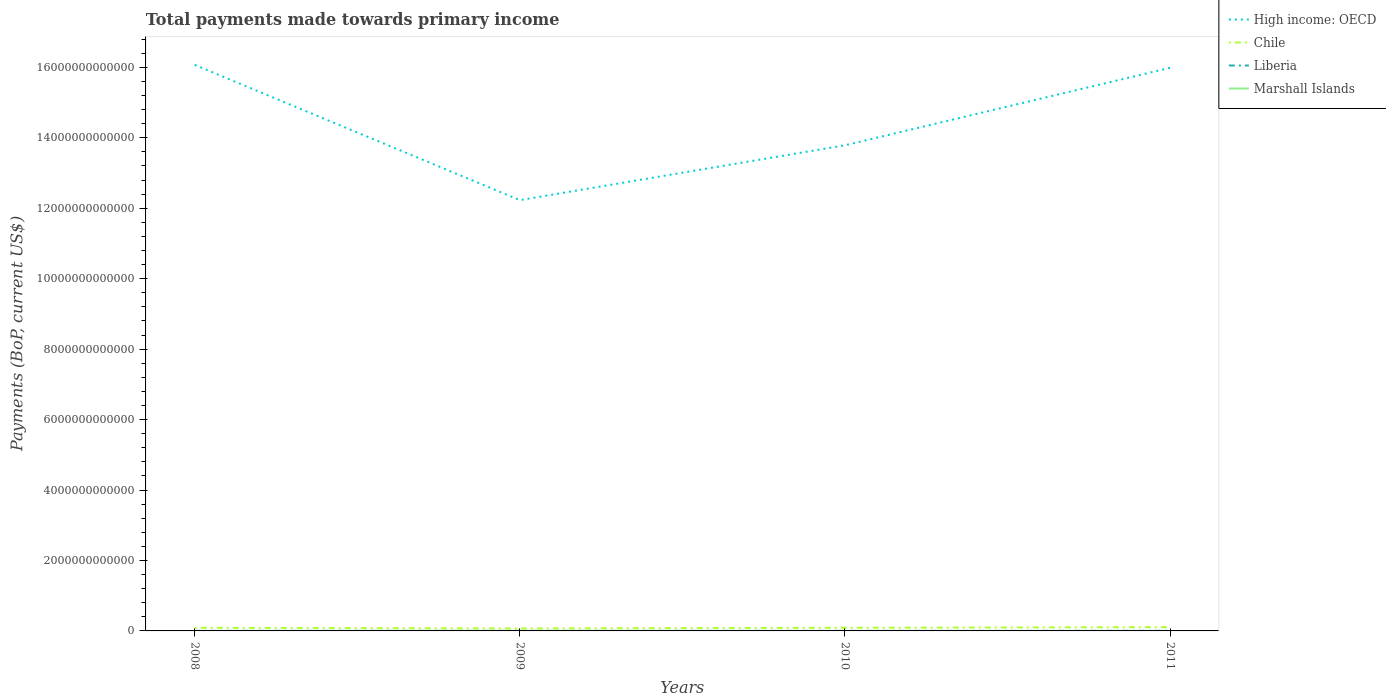How many different coloured lines are there?
Offer a very short reply. 4. Does the line corresponding to Liberia intersect with the line corresponding to High income: OECD?
Your response must be concise. No. Is the number of lines equal to the number of legend labels?
Provide a short and direct response. Yes. Across all years, what is the maximum total payments made towards primary income in Marshall Islands?
Provide a succinct answer. 1.52e+08. In which year was the total payments made towards primary income in Liberia maximum?
Ensure brevity in your answer.  2010. What is the total total payments made towards primary income in Liberia in the graph?
Offer a terse response. 5.06e+08. What is the difference between the highest and the second highest total payments made towards primary income in Chile?
Ensure brevity in your answer.  3.89e+1. What is the difference between the highest and the lowest total payments made towards primary income in Marshall Islands?
Provide a succinct answer. 2. How many lines are there?
Offer a very short reply. 4. How many years are there in the graph?
Offer a terse response. 4. What is the difference between two consecutive major ticks on the Y-axis?
Provide a succinct answer. 2.00e+12. Does the graph contain any zero values?
Offer a terse response. No. Where does the legend appear in the graph?
Provide a short and direct response. Top right. What is the title of the graph?
Your answer should be very brief. Total payments made towards primary income. Does "Romania" appear as one of the legend labels in the graph?
Your response must be concise. No. What is the label or title of the X-axis?
Offer a terse response. Years. What is the label or title of the Y-axis?
Ensure brevity in your answer.  Payments (BoP, current US$). What is the Payments (BoP, current US$) of High income: OECD in 2008?
Give a very brief answer. 1.61e+13. What is the Payments (BoP, current US$) of Chile in 2008?
Your answer should be very brief. 8.92e+1. What is the Payments (BoP, current US$) in Liberia in 2008?
Make the answer very short. 2.31e+09. What is the Payments (BoP, current US$) of Marshall Islands in 2008?
Your response must be concise. 1.52e+08. What is the Payments (BoP, current US$) in High income: OECD in 2009?
Ensure brevity in your answer.  1.22e+13. What is the Payments (BoP, current US$) in Chile in 2009?
Offer a very short reply. 6.86e+1. What is the Payments (BoP, current US$) in Liberia in 2009?
Provide a short and direct response. 1.85e+09. What is the Payments (BoP, current US$) of Marshall Islands in 2009?
Make the answer very short. 1.70e+08. What is the Payments (BoP, current US$) in High income: OECD in 2010?
Give a very brief answer. 1.38e+13. What is the Payments (BoP, current US$) of Chile in 2010?
Make the answer very short. 8.99e+1. What is the Payments (BoP, current US$) of Liberia in 2010?
Make the answer very short. 1.80e+09. What is the Payments (BoP, current US$) of Marshall Islands in 2010?
Offer a very short reply. 1.76e+08. What is the Payments (BoP, current US$) of High income: OECD in 2011?
Keep it short and to the point. 1.60e+13. What is the Payments (BoP, current US$) of Chile in 2011?
Provide a succinct answer. 1.07e+11. What is the Payments (BoP, current US$) of Liberia in 2011?
Provide a short and direct response. 3.33e+09. What is the Payments (BoP, current US$) in Marshall Islands in 2011?
Your answer should be compact. 1.93e+08. Across all years, what is the maximum Payments (BoP, current US$) in High income: OECD?
Offer a very short reply. 1.61e+13. Across all years, what is the maximum Payments (BoP, current US$) of Chile?
Give a very brief answer. 1.07e+11. Across all years, what is the maximum Payments (BoP, current US$) in Liberia?
Offer a terse response. 3.33e+09. Across all years, what is the maximum Payments (BoP, current US$) of Marshall Islands?
Ensure brevity in your answer.  1.93e+08. Across all years, what is the minimum Payments (BoP, current US$) of High income: OECD?
Ensure brevity in your answer.  1.22e+13. Across all years, what is the minimum Payments (BoP, current US$) in Chile?
Offer a terse response. 6.86e+1. Across all years, what is the minimum Payments (BoP, current US$) in Liberia?
Your response must be concise. 1.80e+09. Across all years, what is the minimum Payments (BoP, current US$) of Marshall Islands?
Ensure brevity in your answer.  1.52e+08. What is the total Payments (BoP, current US$) in High income: OECD in the graph?
Your answer should be very brief. 5.81e+13. What is the total Payments (BoP, current US$) of Chile in the graph?
Keep it short and to the point. 3.55e+11. What is the total Payments (BoP, current US$) of Liberia in the graph?
Provide a succinct answer. 9.29e+09. What is the total Payments (BoP, current US$) in Marshall Islands in the graph?
Provide a succinct answer. 6.91e+08. What is the difference between the Payments (BoP, current US$) in High income: OECD in 2008 and that in 2009?
Offer a very short reply. 3.84e+12. What is the difference between the Payments (BoP, current US$) in Chile in 2008 and that in 2009?
Keep it short and to the point. 2.07e+1. What is the difference between the Payments (BoP, current US$) of Liberia in 2008 and that in 2009?
Give a very brief answer. 4.61e+08. What is the difference between the Payments (BoP, current US$) of Marshall Islands in 2008 and that in 2009?
Provide a succinct answer. -1.81e+07. What is the difference between the Payments (BoP, current US$) in High income: OECD in 2008 and that in 2010?
Offer a terse response. 2.28e+12. What is the difference between the Payments (BoP, current US$) in Chile in 2008 and that in 2010?
Ensure brevity in your answer.  -6.36e+08. What is the difference between the Payments (BoP, current US$) of Liberia in 2008 and that in 2010?
Make the answer very short. 5.06e+08. What is the difference between the Payments (BoP, current US$) of Marshall Islands in 2008 and that in 2010?
Your answer should be compact. -2.37e+07. What is the difference between the Payments (BoP, current US$) in High income: OECD in 2008 and that in 2011?
Provide a short and direct response. 8.32e+1. What is the difference between the Payments (BoP, current US$) in Chile in 2008 and that in 2011?
Give a very brief answer. -1.82e+1. What is the difference between the Payments (BoP, current US$) in Liberia in 2008 and that in 2011?
Make the answer very short. -1.01e+09. What is the difference between the Payments (BoP, current US$) in Marshall Islands in 2008 and that in 2011?
Ensure brevity in your answer.  -4.05e+07. What is the difference between the Payments (BoP, current US$) of High income: OECD in 2009 and that in 2010?
Keep it short and to the point. -1.56e+12. What is the difference between the Payments (BoP, current US$) of Chile in 2009 and that in 2010?
Keep it short and to the point. -2.13e+1. What is the difference between the Payments (BoP, current US$) of Liberia in 2009 and that in 2010?
Provide a succinct answer. 4.54e+07. What is the difference between the Payments (BoP, current US$) in Marshall Islands in 2009 and that in 2010?
Make the answer very short. -5.53e+06. What is the difference between the Payments (BoP, current US$) in High income: OECD in 2009 and that in 2011?
Ensure brevity in your answer.  -3.76e+12. What is the difference between the Payments (BoP, current US$) in Chile in 2009 and that in 2011?
Offer a terse response. -3.89e+1. What is the difference between the Payments (BoP, current US$) in Liberia in 2009 and that in 2011?
Ensure brevity in your answer.  -1.48e+09. What is the difference between the Payments (BoP, current US$) of Marshall Islands in 2009 and that in 2011?
Your answer should be very brief. -2.23e+07. What is the difference between the Payments (BoP, current US$) of High income: OECD in 2010 and that in 2011?
Your answer should be very brief. -2.20e+12. What is the difference between the Payments (BoP, current US$) of Chile in 2010 and that in 2011?
Your answer should be compact. -1.76e+1. What is the difference between the Payments (BoP, current US$) of Liberia in 2010 and that in 2011?
Make the answer very short. -1.52e+09. What is the difference between the Payments (BoP, current US$) of Marshall Islands in 2010 and that in 2011?
Provide a short and direct response. -1.68e+07. What is the difference between the Payments (BoP, current US$) of High income: OECD in 2008 and the Payments (BoP, current US$) of Chile in 2009?
Keep it short and to the point. 1.60e+13. What is the difference between the Payments (BoP, current US$) in High income: OECD in 2008 and the Payments (BoP, current US$) in Liberia in 2009?
Provide a short and direct response. 1.61e+13. What is the difference between the Payments (BoP, current US$) in High income: OECD in 2008 and the Payments (BoP, current US$) in Marshall Islands in 2009?
Give a very brief answer. 1.61e+13. What is the difference between the Payments (BoP, current US$) in Chile in 2008 and the Payments (BoP, current US$) in Liberia in 2009?
Your response must be concise. 8.74e+1. What is the difference between the Payments (BoP, current US$) in Chile in 2008 and the Payments (BoP, current US$) in Marshall Islands in 2009?
Keep it short and to the point. 8.91e+1. What is the difference between the Payments (BoP, current US$) in Liberia in 2008 and the Payments (BoP, current US$) in Marshall Islands in 2009?
Your answer should be very brief. 2.14e+09. What is the difference between the Payments (BoP, current US$) in High income: OECD in 2008 and the Payments (BoP, current US$) in Chile in 2010?
Your answer should be compact. 1.60e+13. What is the difference between the Payments (BoP, current US$) in High income: OECD in 2008 and the Payments (BoP, current US$) in Liberia in 2010?
Offer a terse response. 1.61e+13. What is the difference between the Payments (BoP, current US$) in High income: OECD in 2008 and the Payments (BoP, current US$) in Marshall Islands in 2010?
Offer a terse response. 1.61e+13. What is the difference between the Payments (BoP, current US$) in Chile in 2008 and the Payments (BoP, current US$) in Liberia in 2010?
Keep it short and to the point. 8.74e+1. What is the difference between the Payments (BoP, current US$) of Chile in 2008 and the Payments (BoP, current US$) of Marshall Islands in 2010?
Ensure brevity in your answer.  8.91e+1. What is the difference between the Payments (BoP, current US$) in Liberia in 2008 and the Payments (BoP, current US$) in Marshall Islands in 2010?
Offer a very short reply. 2.13e+09. What is the difference between the Payments (BoP, current US$) in High income: OECD in 2008 and the Payments (BoP, current US$) in Chile in 2011?
Offer a very short reply. 1.60e+13. What is the difference between the Payments (BoP, current US$) in High income: OECD in 2008 and the Payments (BoP, current US$) in Liberia in 2011?
Keep it short and to the point. 1.61e+13. What is the difference between the Payments (BoP, current US$) of High income: OECD in 2008 and the Payments (BoP, current US$) of Marshall Islands in 2011?
Ensure brevity in your answer.  1.61e+13. What is the difference between the Payments (BoP, current US$) of Chile in 2008 and the Payments (BoP, current US$) of Liberia in 2011?
Offer a terse response. 8.59e+1. What is the difference between the Payments (BoP, current US$) of Chile in 2008 and the Payments (BoP, current US$) of Marshall Islands in 2011?
Keep it short and to the point. 8.91e+1. What is the difference between the Payments (BoP, current US$) of Liberia in 2008 and the Payments (BoP, current US$) of Marshall Islands in 2011?
Keep it short and to the point. 2.12e+09. What is the difference between the Payments (BoP, current US$) of High income: OECD in 2009 and the Payments (BoP, current US$) of Chile in 2010?
Provide a succinct answer. 1.21e+13. What is the difference between the Payments (BoP, current US$) of High income: OECD in 2009 and the Payments (BoP, current US$) of Liberia in 2010?
Offer a terse response. 1.22e+13. What is the difference between the Payments (BoP, current US$) of High income: OECD in 2009 and the Payments (BoP, current US$) of Marshall Islands in 2010?
Provide a succinct answer. 1.22e+13. What is the difference between the Payments (BoP, current US$) in Chile in 2009 and the Payments (BoP, current US$) in Liberia in 2010?
Provide a succinct answer. 6.68e+1. What is the difference between the Payments (BoP, current US$) in Chile in 2009 and the Payments (BoP, current US$) in Marshall Islands in 2010?
Keep it short and to the point. 6.84e+1. What is the difference between the Payments (BoP, current US$) of Liberia in 2009 and the Payments (BoP, current US$) of Marshall Islands in 2010?
Provide a succinct answer. 1.67e+09. What is the difference between the Payments (BoP, current US$) in High income: OECD in 2009 and the Payments (BoP, current US$) in Chile in 2011?
Your answer should be very brief. 1.21e+13. What is the difference between the Payments (BoP, current US$) of High income: OECD in 2009 and the Payments (BoP, current US$) of Liberia in 2011?
Your answer should be compact. 1.22e+13. What is the difference between the Payments (BoP, current US$) of High income: OECD in 2009 and the Payments (BoP, current US$) of Marshall Islands in 2011?
Keep it short and to the point. 1.22e+13. What is the difference between the Payments (BoP, current US$) in Chile in 2009 and the Payments (BoP, current US$) in Liberia in 2011?
Your answer should be compact. 6.52e+1. What is the difference between the Payments (BoP, current US$) in Chile in 2009 and the Payments (BoP, current US$) in Marshall Islands in 2011?
Your answer should be very brief. 6.84e+1. What is the difference between the Payments (BoP, current US$) in Liberia in 2009 and the Payments (BoP, current US$) in Marshall Islands in 2011?
Your answer should be very brief. 1.66e+09. What is the difference between the Payments (BoP, current US$) of High income: OECD in 2010 and the Payments (BoP, current US$) of Chile in 2011?
Offer a terse response. 1.37e+13. What is the difference between the Payments (BoP, current US$) of High income: OECD in 2010 and the Payments (BoP, current US$) of Liberia in 2011?
Your answer should be very brief. 1.38e+13. What is the difference between the Payments (BoP, current US$) in High income: OECD in 2010 and the Payments (BoP, current US$) in Marshall Islands in 2011?
Give a very brief answer. 1.38e+13. What is the difference between the Payments (BoP, current US$) in Chile in 2010 and the Payments (BoP, current US$) in Liberia in 2011?
Keep it short and to the point. 8.66e+1. What is the difference between the Payments (BoP, current US$) of Chile in 2010 and the Payments (BoP, current US$) of Marshall Islands in 2011?
Keep it short and to the point. 8.97e+1. What is the difference between the Payments (BoP, current US$) in Liberia in 2010 and the Payments (BoP, current US$) in Marshall Islands in 2011?
Provide a short and direct response. 1.61e+09. What is the average Payments (BoP, current US$) in High income: OECD per year?
Provide a short and direct response. 1.45e+13. What is the average Payments (BoP, current US$) of Chile per year?
Your answer should be compact. 8.88e+1. What is the average Payments (BoP, current US$) in Liberia per year?
Offer a terse response. 2.32e+09. What is the average Payments (BoP, current US$) in Marshall Islands per year?
Provide a succinct answer. 1.73e+08. In the year 2008, what is the difference between the Payments (BoP, current US$) in High income: OECD and Payments (BoP, current US$) in Chile?
Make the answer very short. 1.60e+13. In the year 2008, what is the difference between the Payments (BoP, current US$) of High income: OECD and Payments (BoP, current US$) of Liberia?
Provide a succinct answer. 1.61e+13. In the year 2008, what is the difference between the Payments (BoP, current US$) of High income: OECD and Payments (BoP, current US$) of Marshall Islands?
Your answer should be compact. 1.61e+13. In the year 2008, what is the difference between the Payments (BoP, current US$) of Chile and Payments (BoP, current US$) of Liberia?
Give a very brief answer. 8.69e+1. In the year 2008, what is the difference between the Payments (BoP, current US$) of Chile and Payments (BoP, current US$) of Marshall Islands?
Your response must be concise. 8.91e+1. In the year 2008, what is the difference between the Payments (BoP, current US$) of Liberia and Payments (BoP, current US$) of Marshall Islands?
Your answer should be compact. 2.16e+09. In the year 2009, what is the difference between the Payments (BoP, current US$) of High income: OECD and Payments (BoP, current US$) of Chile?
Make the answer very short. 1.22e+13. In the year 2009, what is the difference between the Payments (BoP, current US$) of High income: OECD and Payments (BoP, current US$) of Liberia?
Make the answer very short. 1.22e+13. In the year 2009, what is the difference between the Payments (BoP, current US$) in High income: OECD and Payments (BoP, current US$) in Marshall Islands?
Ensure brevity in your answer.  1.22e+13. In the year 2009, what is the difference between the Payments (BoP, current US$) of Chile and Payments (BoP, current US$) of Liberia?
Provide a short and direct response. 6.67e+1. In the year 2009, what is the difference between the Payments (BoP, current US$) of Chile and Payments (BoP, current US$) of Marshall Islands?
Make the answer very short. 6.84e+1. In the year 2009, what is the difference between the Payments (BoP, current US$) in Liberia and Payments (BoP, current US$) in Marshall Islands?
Provide a short and direct response. 1.68e+09. In the year 2010, what is the difference between the Payments (BoP, current US$) in High income: OECD and Payments (BoP, current US$) in Chile?
Your response must be concise. 1.37e+13. In the year 2010, what is the difference between the Payments (BoP, current US$) in High income: OECD and Payments (BoP, current US$) in Liberia?
Ensure brevity in your answer.  1.38e+13. In the year 2010, what is the difference between the Payments (BoP, current US$) of High income: OECD and Payments (BoP, current US$) of Marshall Islands?
Your answer should be compact. 1.38e+13. In the year 2010, what is the difference between the Payments (BoP, current US$) in Chile and Payments (BoP, current US$) in Liberia?
Ensure brevity in your answer.  8.81e+1. In the year 2010, what is the difference between the Payments (BoP, current US$) in Chile and Payments (BoP, current US$) in Marshall Islands?
Your answer should be compact. 8.97e+1. In the year 2010, what is the difference between the Payments (BoP, current US$) of Liberia and Payments (BoP, current US$) of Marshall Islands?
Keep it short and to the point. 1.63e+09. In the year 2011, what is the difference between the Payments (BoP, current US$) in High income: OECD and Payments (BoP, current US$) in Chile?
Offer a very short reply. 1.59e+13. In the year 2011, what is the difference between the Payments (BoP, current US$) in High income: OECD and Payments (BoP, current US$) in Liberia?
Give a very brief answer. 1.60e+13. In the year 2011, what is the difference between the Payments (BoP, current US$) of High income: OECD and Payments (BoP, current US$) of Marshall Islands?
Your answer should be very brief. 1.60e+13. In the year 2011, what is the difference between the Payments (BoP, current US$) of Chile and Payments (BoP, current US$) of Liberia?
Give a very brief answer. 1.04e+11. In the year 2011, what is the difference between the Payments (BoP, current US$) of Chile and Payments (BoP, current US$) of Marshall Islands?
Your answer should be compact. 1.07e+11. In the year 2011, what is the difference between the Payments (BoP, current US$) of Liberia and Payments (BoP, current US$) of Marshall Islands?
Offer a terse response. 3.13e+09. What is the ratio of the Payments (BoP, current US$) of High income: OECD in 2008 to that in 2009?
Offer a terse response. 1.31. What is the ratio of the Payments (BoP, current US$) in Chile in 2008 to that in 2009?
Your response must be concise. 1.3. What is the ratio of the Payments (BoP, current US$) in Liberia in 2008 to that in 2009?
Keep it short and to the point. 1.25. What is the ratio of the Payments (BoP, current US$) of Marshall Islands in 2008 to that in 2009?
Your answer should be very brief. 0.89. What is the ratio of the Payments (BoP, current US$) of High income: OECD in 2008 to that in 2010?
Offer a terse response. 1.17. What is the ratio of the Payments (BoP, current US$) of Chile in 2008 to that in 2010?
Keep it short and to the point. 0.99. What is the ratio of the Payments (BoP, current US$) of Liberia in 2008 to that in 2010?
Offer a terse response. 1.28. What is the ratio of the Payments (BoP, current US$) of Marshall Islands in 2008 to that in 2010?
Offer a terse response. 0.87. What is the ratio of the Payments (BoP, current US$) of Chile in 2008 to that in 2011?
Ensure brevity in your answer.  0.83. What is the ratio of the Payments (BoP, current US$) of Liberia in 2008 to that in 2011?
Offer a very short reply. 0.69. What is the ratio of the Payments (BoP, current US$) in Marshall Islands in 2008 to that in 2011?
Ensure brevity in your answer.  0.79. What is the ratio of the Payments (BoP, current US$) of High income: OECD in 2009 to that in 2010?
Offer a terse response. 0.89. What is the ratio of the Payments (BoP, current US$) in Chile in 2009 to that in 2010?
Give a very brief answer. 0.76. What is the ratio of the Payments (BoP, current US$) in Liberia in 2009 to that in 2010?
Offer a terse response. 1.03. What is the ratio of the Payments (BoP, current US$) in Marshall Islands in 2009 to that in 2010?
Ensure brevity in your answer.  0.97. What is the ratio of the Payments (BoP, current US$) of High income: OECD in 2009 to that in 2011?
Your response must be concise. 0.77. What is the ratio of the Payments (BoP, current US$) in Chile in 2009 to that in 2011?
Make the answer very short. 0.64. What is the ratio of the Payments (BoP, current US$) in Liberia in 2009 to that in 2011?
Your answer should be compact. 0.56. What is the ratio of the Payments (BoP, current US$) of Marshall Islands in 2009 to that in 2011?
Give a very brief answer. 0.88. What is the ratio of the Payments (BoP, current US$) in High income: OECD in 2010 to that in 2011?
Keep it short and to the point. 0.86. What is the ratio of the Payments (BoP, current US$) of Chile in 2010 to that in 2011?
Keep it short and to the point. 0.84. What is the ratio of the Payments (BoP, current US$) of Liberia in 2010 to that in 2011?
Your response must be concise. 0.54. What is the ratio of the Payments (BoP, current US$) of Marshall Islands in 2010 to that in 2011?
Provide a short and direct response. 0.91. What is the difference between the highest and the second highest Payments (BoP, current US$) in High income: OECD?
Provide a succinct answer. 8.32e+1. What is the difference between the highest and the second highest Payments (BoP, current US$) in Chile?
Ensure brevity in your answer.  1.76e+1. What is the difference between the highest and the second highest Payments (BoP, current US$) in Liberia?
Your answer should be compact. 1.01e+09. What is the difference between the highest and the second highest Payments (BoP, current US$) of Marshall Islands?
Keep it short and to the point. 1.68e+07. What is the difference between the highest and the lowest Payments (BoP, current US$) in High income: OECD?
Give a very brief answer. 3.84e+12. What is the difference between the highest and the lowest Payments (BoP, current US$) in Chile?
Your response must be concise. 3.89e+1. What is the difference between the highest and the lowest Payments (BoP, current US$) in Liberia?
Ensure brevity in your answer.  1.52e+09. What is the difference between the highest and the lowest Payments (BoP, current US$) of Marshall Islands?
Make the answer very short. 4.05e+07. 